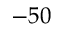<formula> <loc_0><loc_0><loc_500><loc_500>- 5 0</formula> 